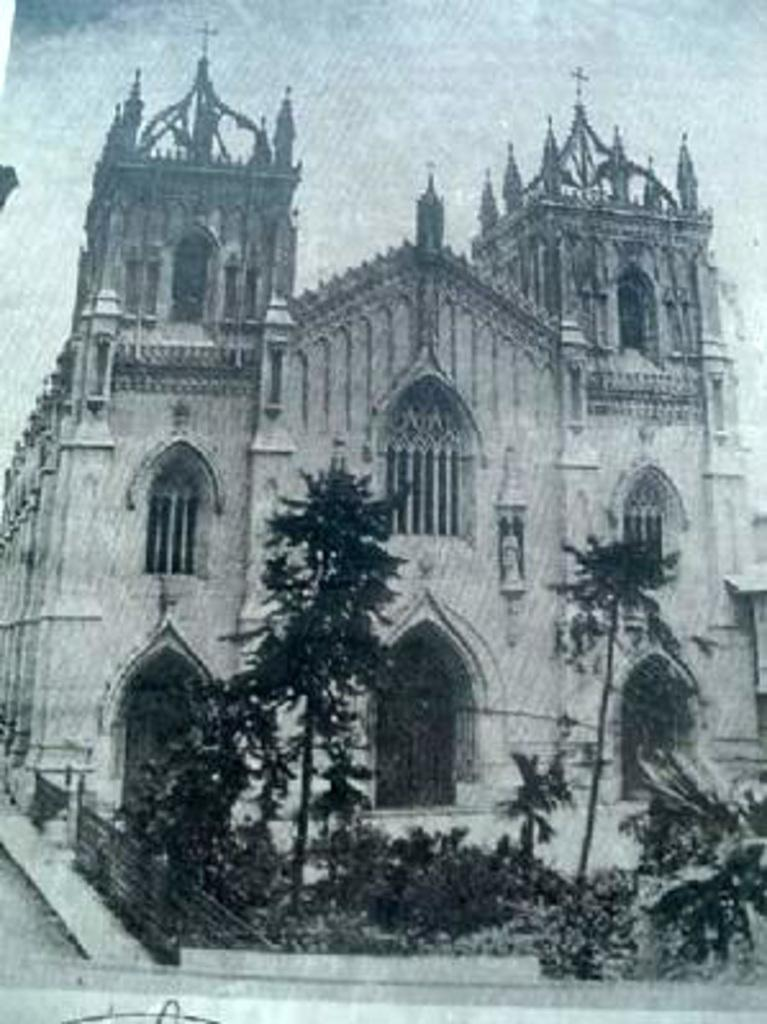What is the main subject of the image? There is a photo of a church in the center of the image. What can be seen in the background of the image? There are trees visible in the image. What type of industry can be seen near the church in the image? There is no industry visible in the image; it only features a photo of a church and trees in the background. What type of trousers is the bear wearing in the image? There is no bear present in the image, so it is not possible to determine what type of trousers it might be wearing. 